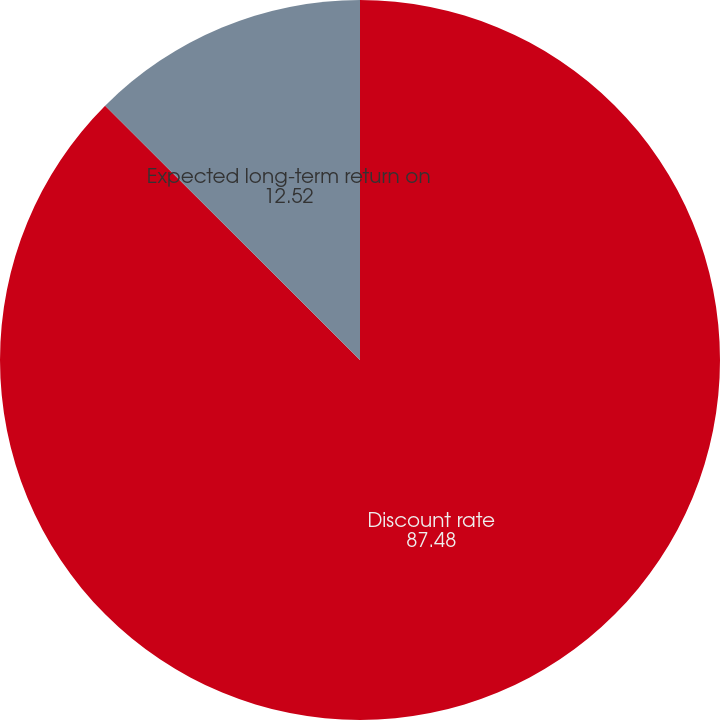Convert chart to OTSL. <chart><loc_0><loc_0><loc_500><loc_500><pie_chart><fcel>Discount rate<fcel>Expected long-term return on<nl><fcel>87.48%<fcel>12.52%<nl></chart> 